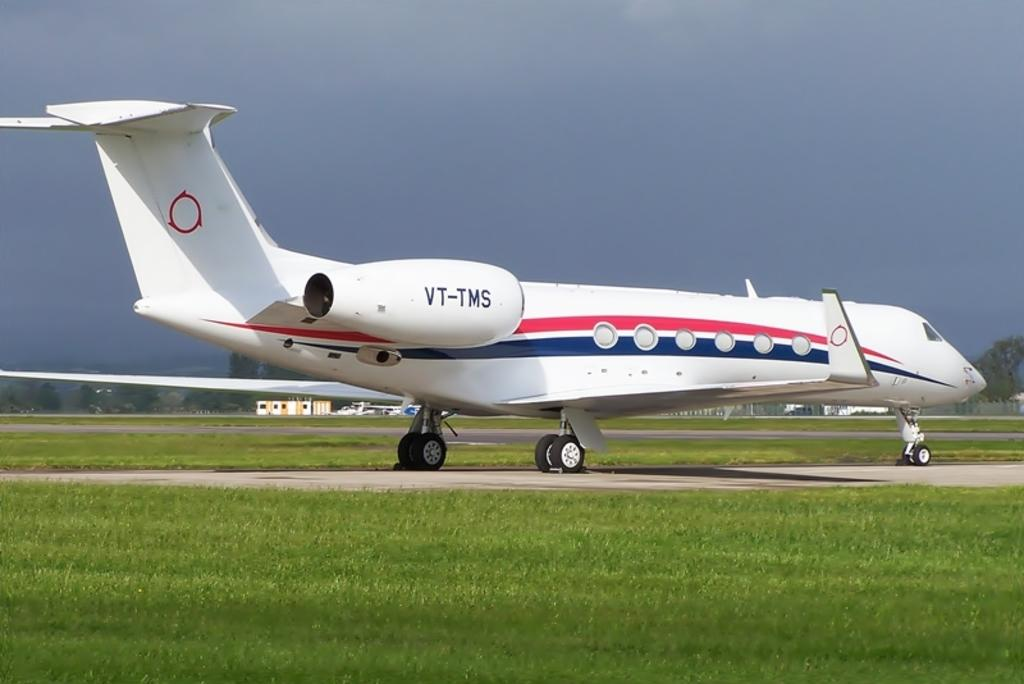<image>
Relay a brief, clear account of the picture shown. the white plane has VT-TMS and a red and blue stripe on it 